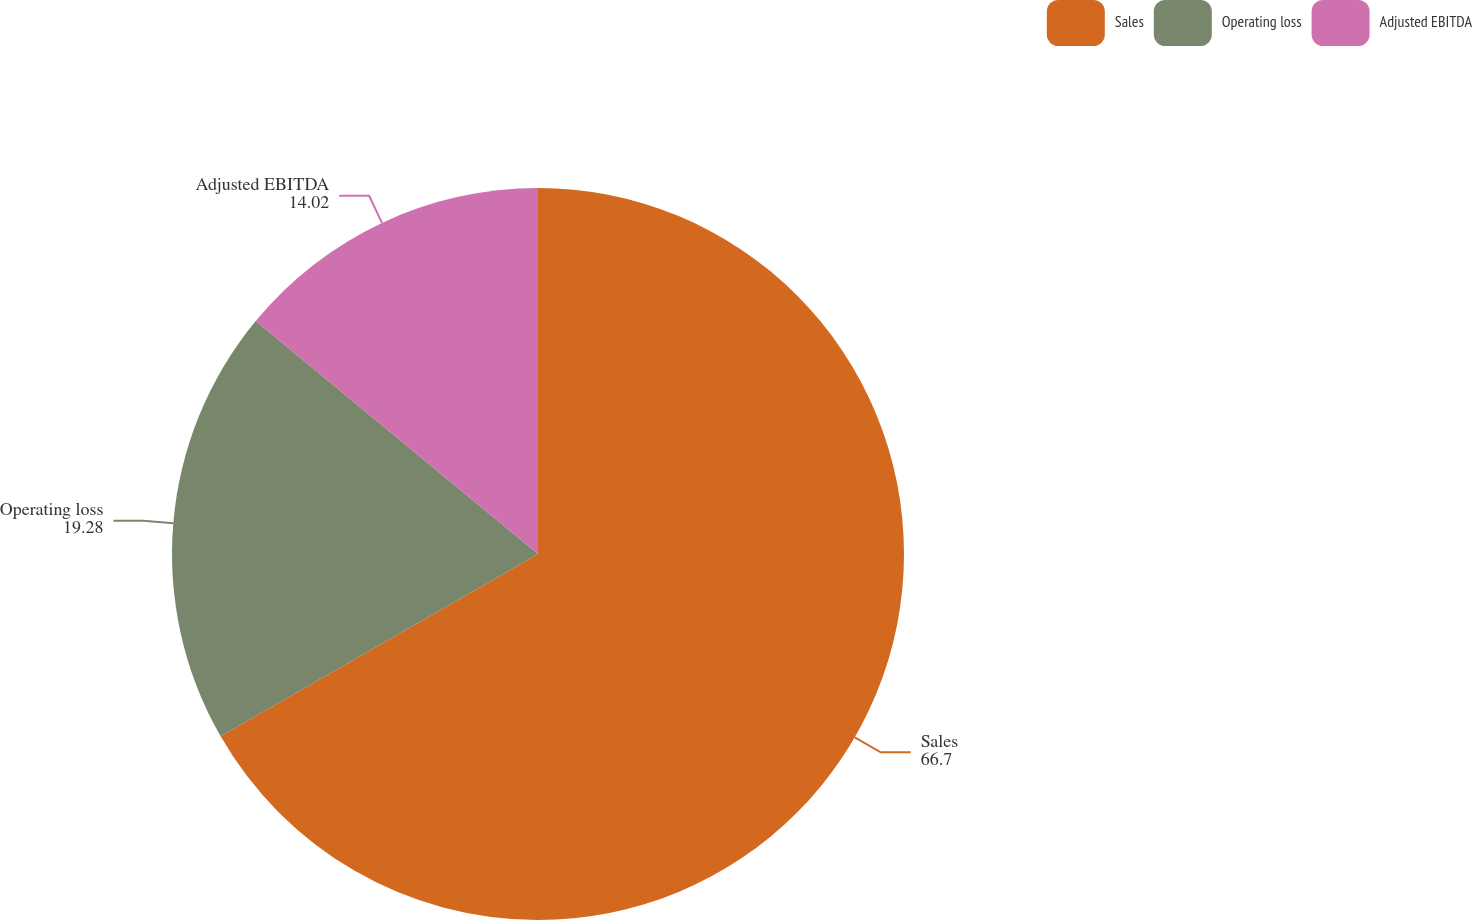<chart> <loc_0><loc_0><loc_500><loc_500><pie_chart><fcel>Sales<fcel>Operating loss<fcel>Adjusted EBITDA<nl><fcel>66.7%<fcel>19.28%<fcel>14.02%<nl></chart> 